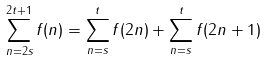<formula> <loc_0><loc_0><loc_500><loc_500>\sum _ { n = 2 s } ^ { 2 t + 1 } f ( n ) = \sum _ { n = s } ^ { t } f ( 2 n ) + \sum _ { n = s } ^ { t } f ( 2 n + 1 )</formula> 